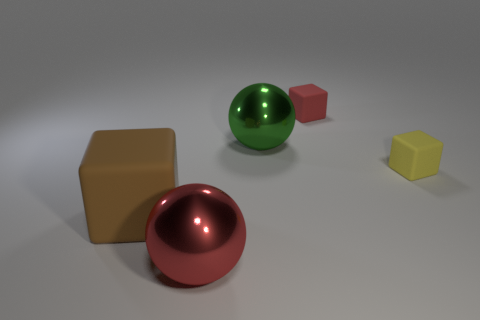Is there a red shiny ball that is behind the shiny thing that is on the right side of the large shiny sphere in front of the small yellow rubber cube?
Provide a short and direct response. No. What number of other things are there of the same shape as the large green thing?
Make the answer very short. 1. There is a object that is both in front of the tiny yellow object and behind the red shiny object; what is its shape?
Provide a succinct answer. Cube. What color is the sphere that is in front of the matte cube to the left of the large shiny object behind the large brown matte object?
Ensure brevity in your answer.  Red. Are there more large red things that are in front of the red matte cube than big brown objects right of the small yellow cube?
Your response must be concise. Yes. How many other objects are the same size as the brown block?
Your answer should be compact. 2. There is a small thing behind the large metallic object that is behind the big rubber thing; what is its material?
Offer a very short reply. Rubber. There is a brown rubber object; are there any green things behind it?
Provide a short and direct response. Yes. Are there more small things behind the red metal thing than big brown rubber objects?
Your answer should be compact. Yes. What is the color of the cube that is the same size as the red metal thing?
Give a very brief answer. Brown. 